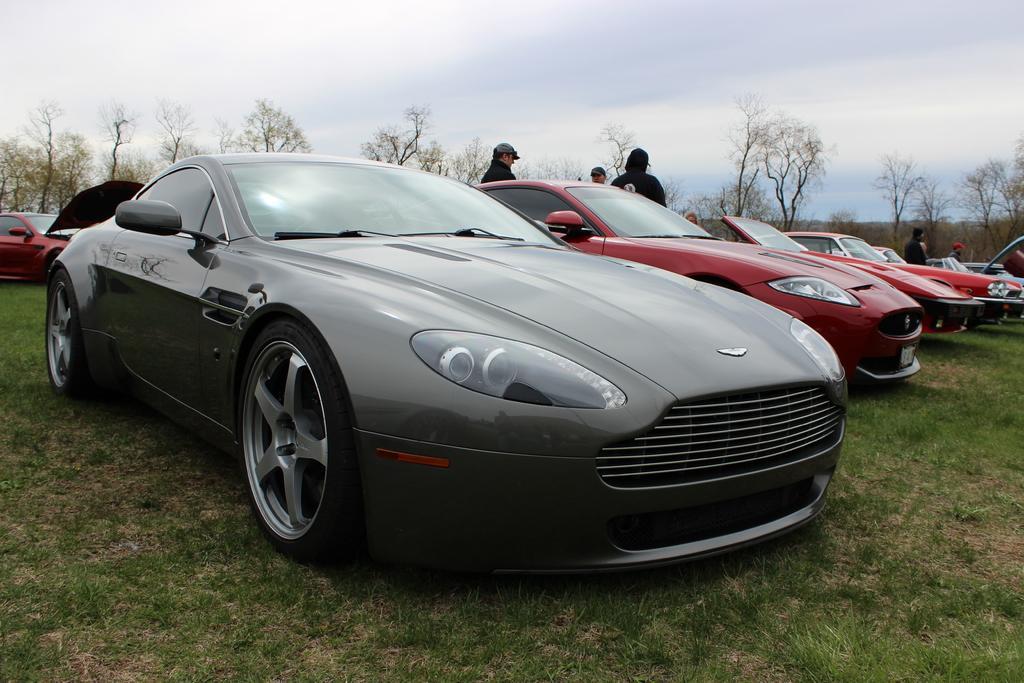Describe this image in one or two sentences. In this picture I can see vehicles on the grass, there are group of people standing, there are trees, and in the background there is sky. 